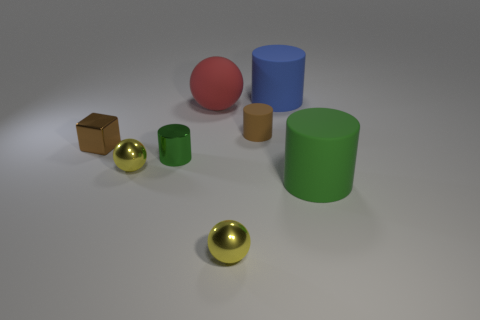Add 2 brown rubber spheres. How many objects exist? 10 Subtract all blue cylinders. How many cylinders are left? 3 Subtract all metal cylinders. How many cylinders are left? 3 Subtract 1 spheres. How many spheres are left? 2 Subtract all cubes. How many objects are left? 7 Subtract all gray cylinders. Subtract all purple balls. How many cylinders are left? 4 Subtract all brown cubes. How many red cylinders are left? 0 Subtract all large red objects. Subtract all large red rubber spheres. How many objects are left? 6 Add 1 green shiny things. How many green shiny things are left? 2 Add 7 red balls. How many red balls exist? 8 